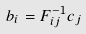Convert formula to latex. <formula><loc_0><loc_0><loc_500><loc_500>b _ { i } = { F } _ { i j } ^ { - 1 } c _ { j }</formula> 